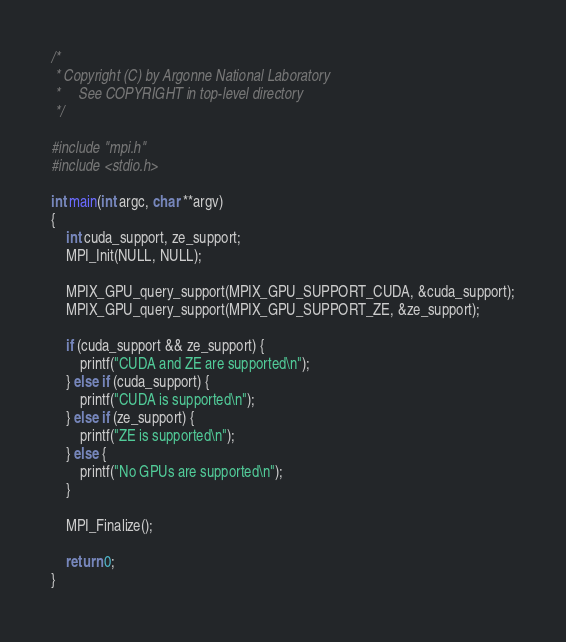Convert code to text. <code><loc_0><loc_0><loc_500><loc_500><_C_>/*
 * Copyright (C) by Argonne National Laboratory
 *     See COPYRIGHT in top-level directory
 */

#include "mpi.h"
#include <stdio.h>

int main(int argc, char **argv)
{
    int cuda_support, ze_support;
    MPI_Init(NULL, NULL);

    MPIX_GPU_query_support(MPIX_GPU_SUPPORT_CUDA, &cuda_support);
    MPIX_GPU_query_support(MPIX_GPU_SUPPORT_ZE, &ze_support);

    if (cuda_support && ze_support) {
        printf("CUDA and ZE are supported\n");
    } else if (cuda_support) {
        printf("CUDA is supported\n");
    } else if (ze_support) {
        printf("ZE is supported\n");
    } else {
        printf("No GPUs are supported\n");
    }

    MPI_Finalize();

    return 0;
}
</code> 